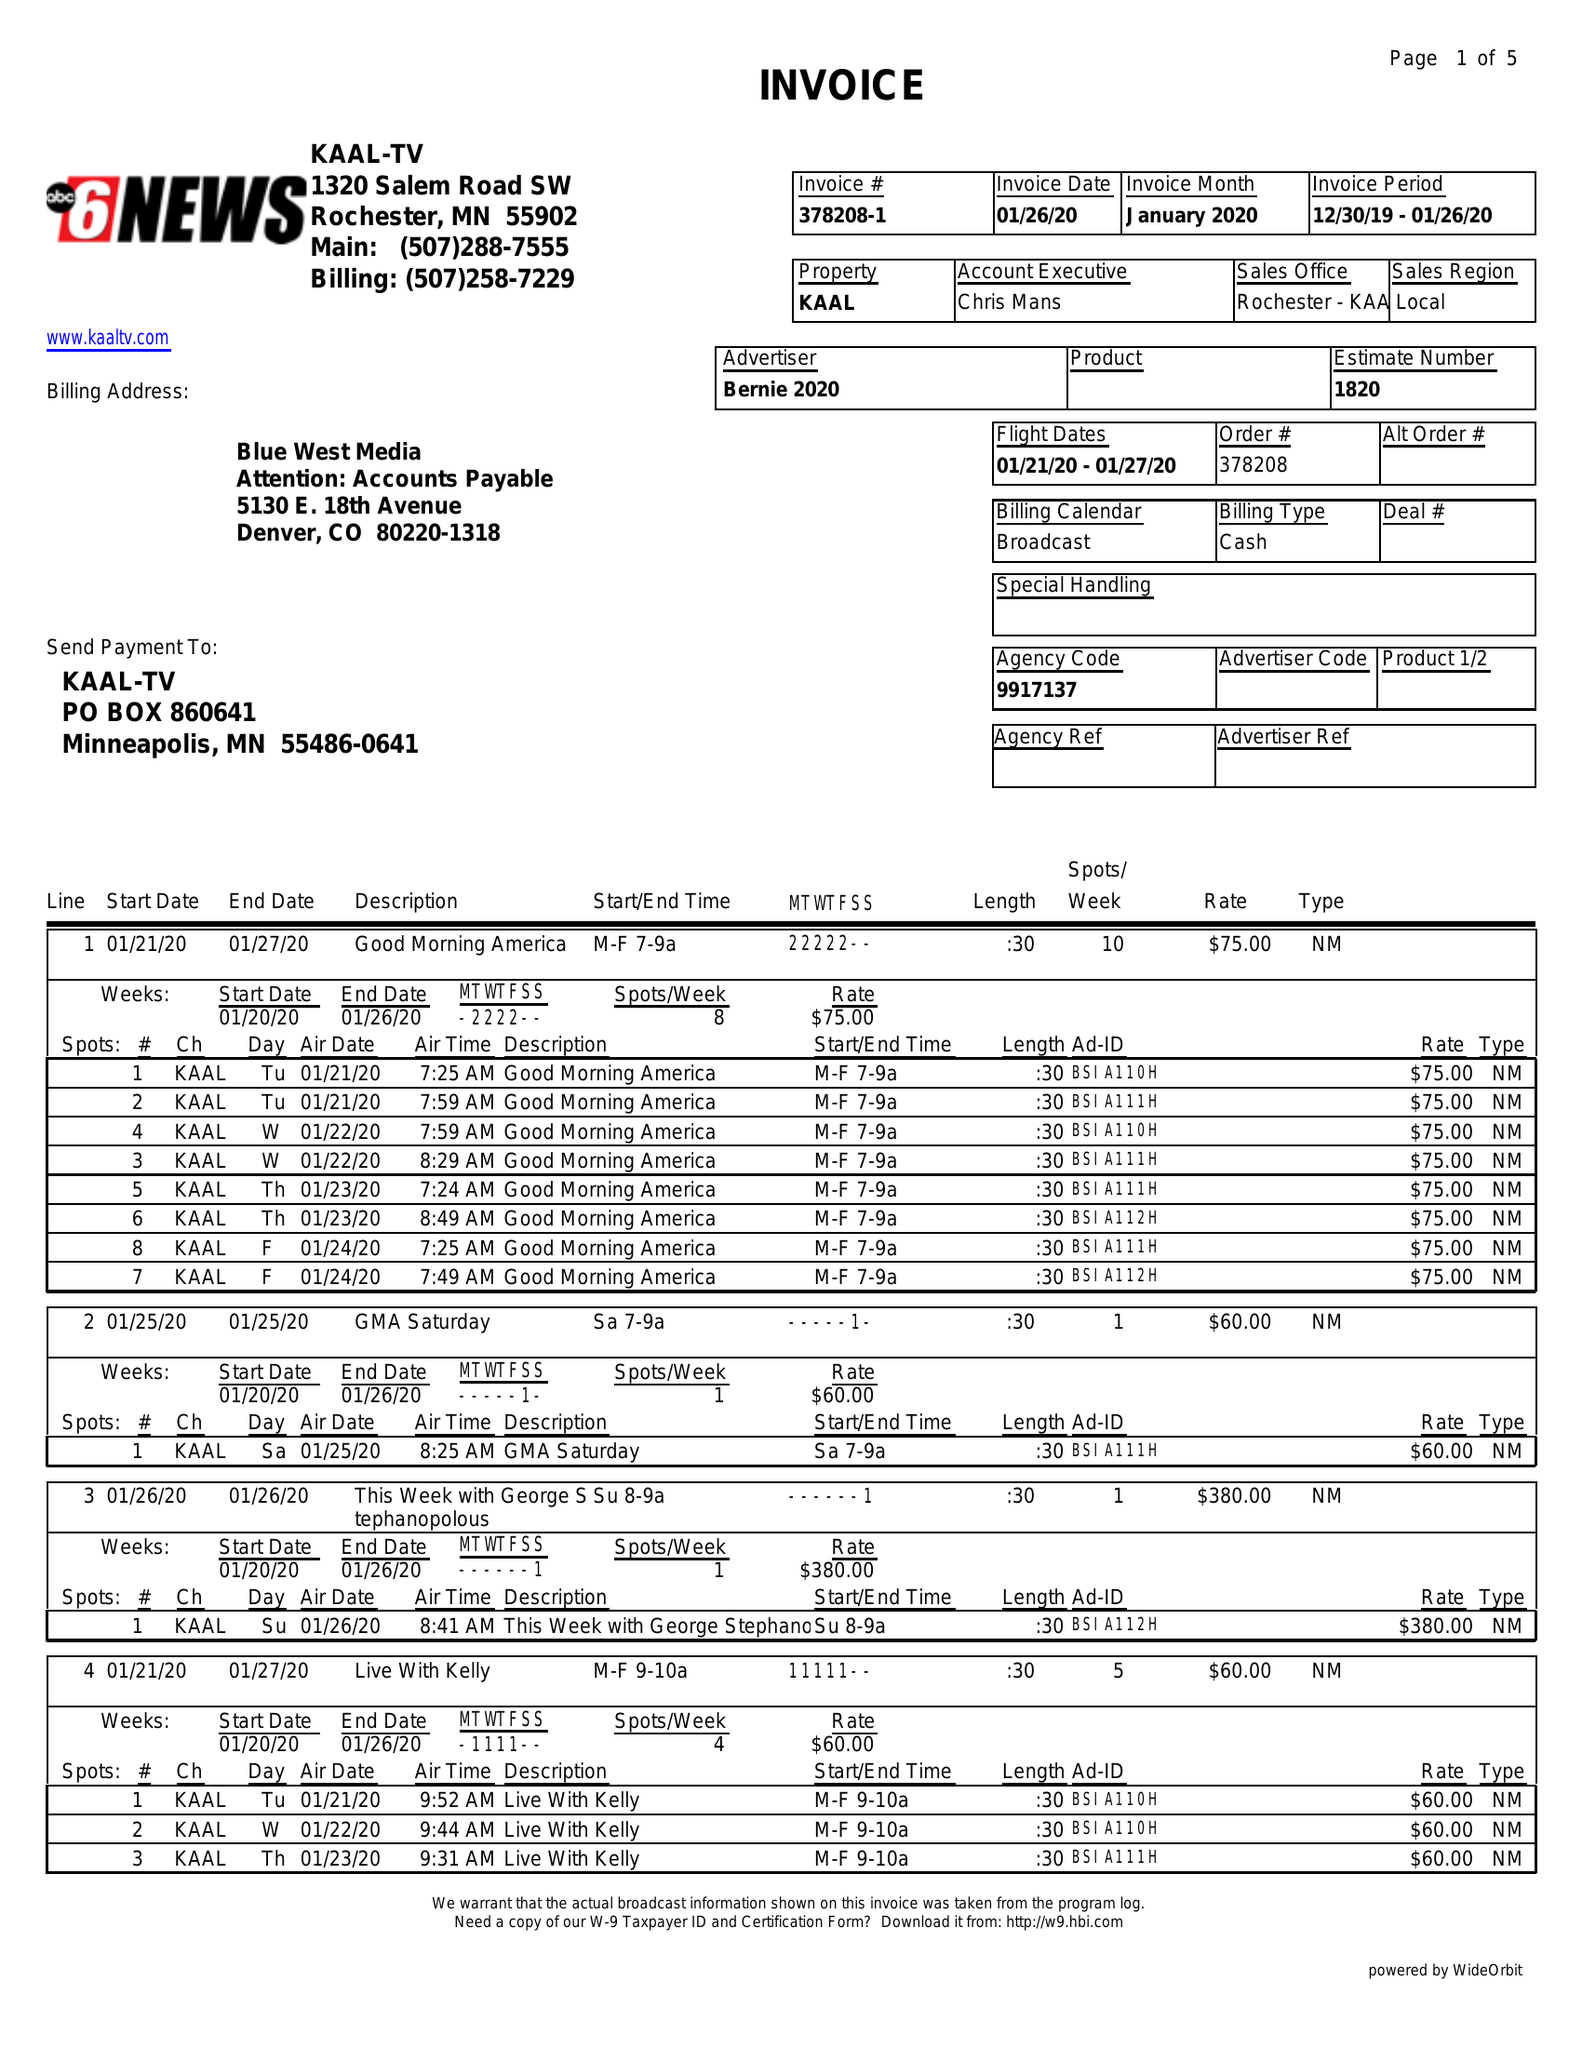What is the value for the contract_num?
Answer the question using a single word or phrase. 378208 